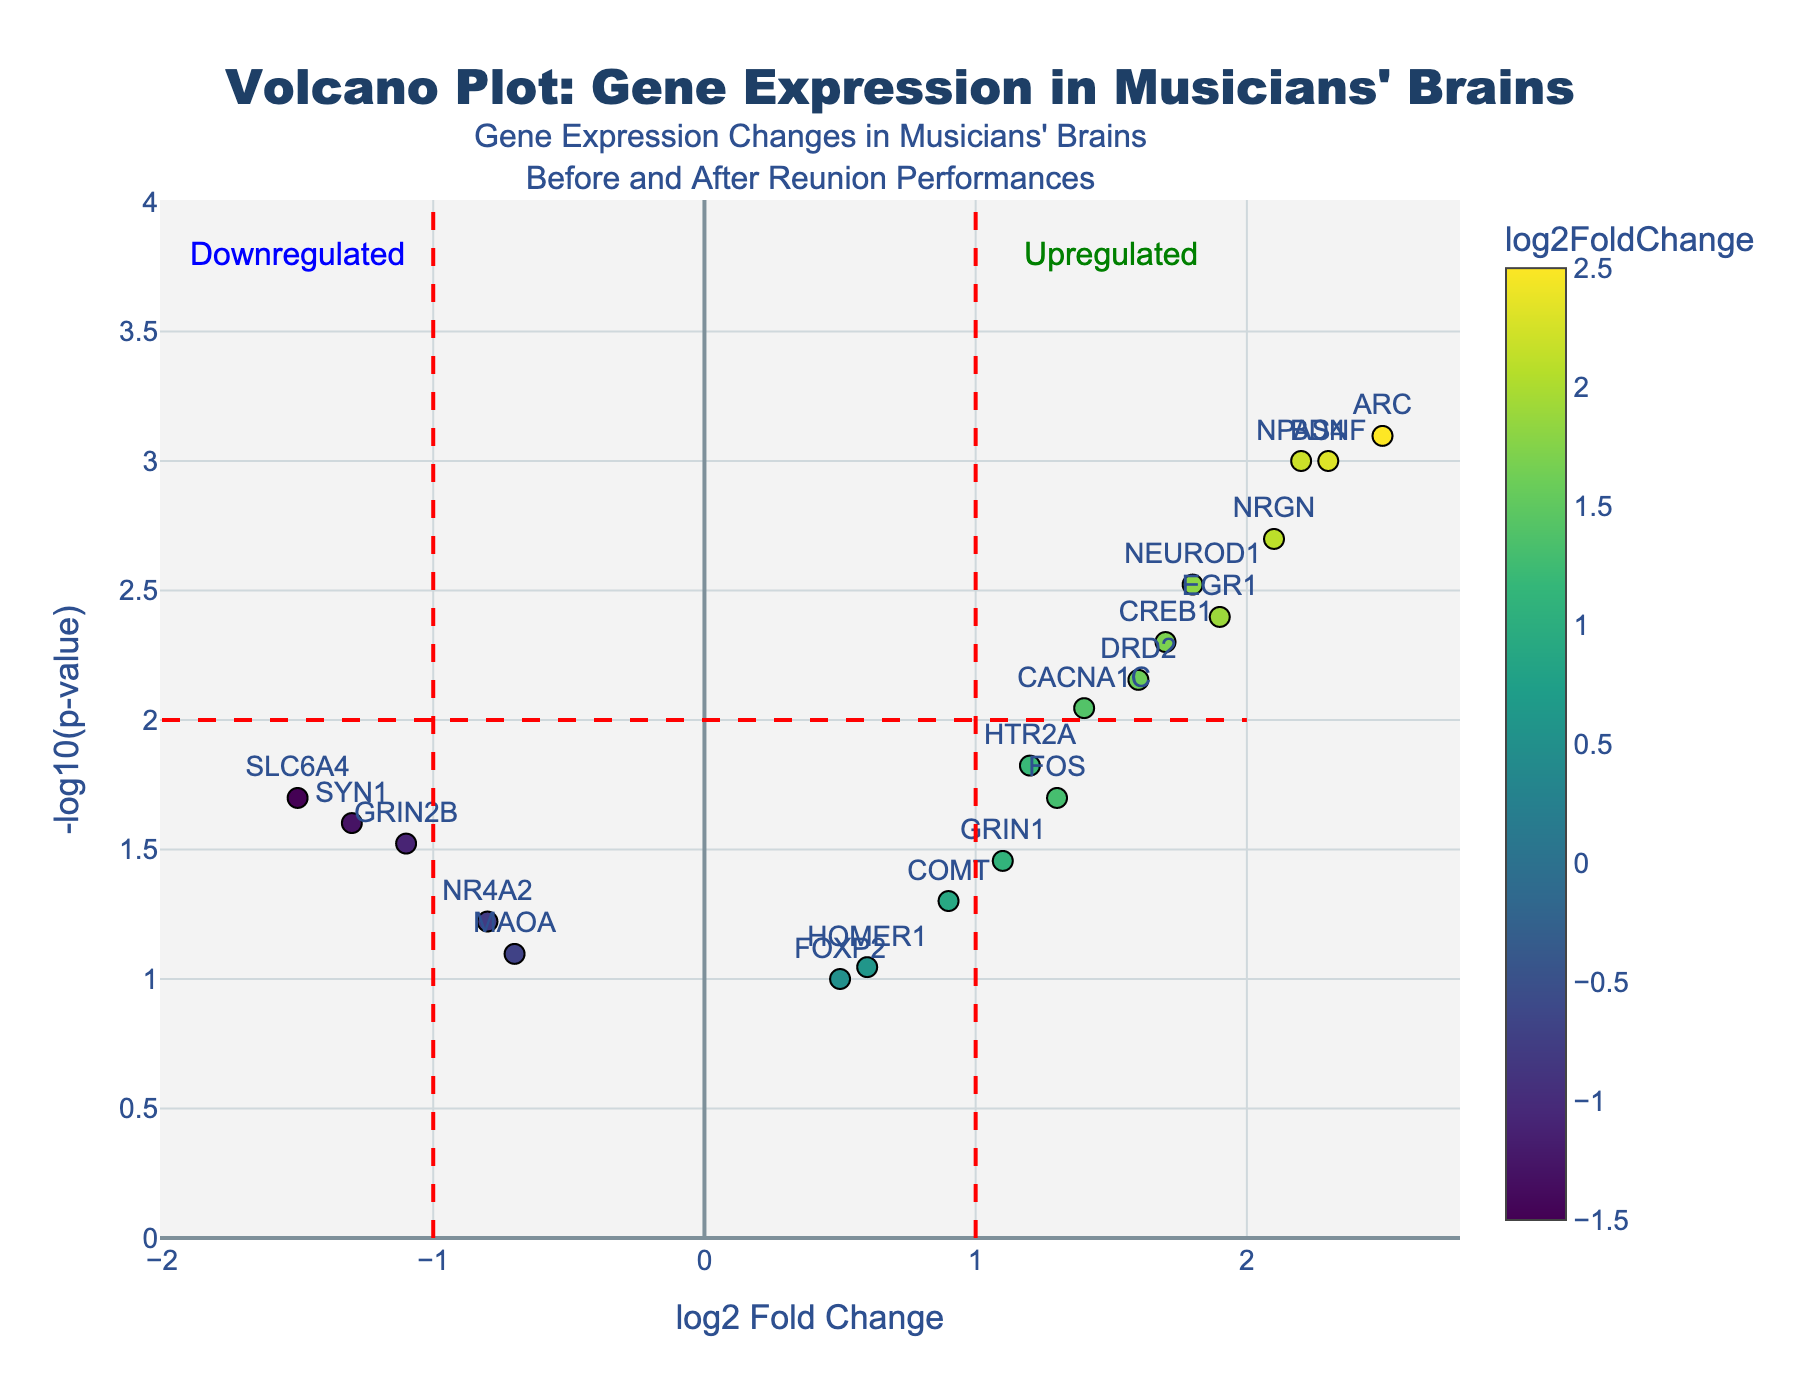How many genes are displayed in the plot? Count the data points or labels on the plot to get the number of displayed genes. Each point represents one gene, and there are 20 genes listed.
Answer: 20 Which gene has the highest log2 fold change? Identify the gene with the highest x-axis value, which is 'ARC' at 2.5.
Answer: ARC Which gene has the most significant p-value? The gene with the highest y-axis value, indicating the largest -log10(p-value), is 'ARC'.
Answer: ARC What is the log2 fold change and p-value of the 'BDNF' gene? Locate the 'BDNF' label on the plot and read the values from hover text or axis labels. It shows log2 fold change of 2.3 and p-value of 0.001.
Answer: log2 fold change: 2.3, p-value: 0.001 How many genes are significantly upregulated (log2 fold change > 1 and p-value < 0.01)? Count the number of genes in the upper right region of the plot where the x-axis value is greater than 1, and the y-axis value (indicating significance) is also high. 7 genes fall into this category (BDNF, NPAS4, NRGN, ARC, DRD2, CACNA1C, CREB1).
Answer: 7 Compare the log2 fold change of 'DRD2' and 'SLC6A4'. Which one is higher? Locate both 'DRD2' and 'SLC6A4' on the plot. 'DRD2' has a log2 fold change of 1.6, while 'SLC6A4' has -1.5.
Answer: DRD2 Which quadrant contains the 'MAOA' gene? Identify the 'MAOA' label's position relative to the origin (0,0). 'MAOA' is in the lower left quadrant with negative log2 fold change and positive -log10(p-value).
Answer: Lower left Are any genes downregulated with significant p-values (log2 fold change < -1 and p-value < 0.05)? Look for data points in the lower left region of the plot. 'SLC6A4' and 'SYN1' meet these criteria.
Answer: SLC6A4, SYN1 What is the log2 fold change range of the genes displayed? The x-axis spans from approximately -1.5 ('SLC6A4') to 2.5 ('ARC').
Answer: -1.5 to 2.5 What annotation text is displayed in the plot's upper right corner? The plot's upper right corner shows "Upregulated" with green font.
Answer: Upregulated 